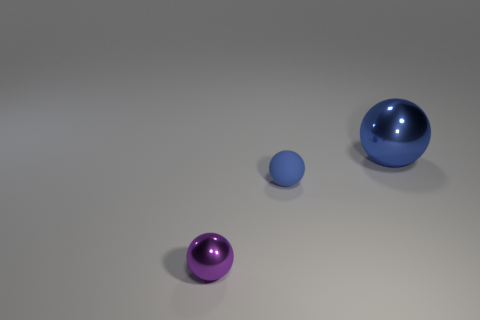There is a metal thing that is right of the small purple ball; is its shape the same as the purple shiny thing? yes 